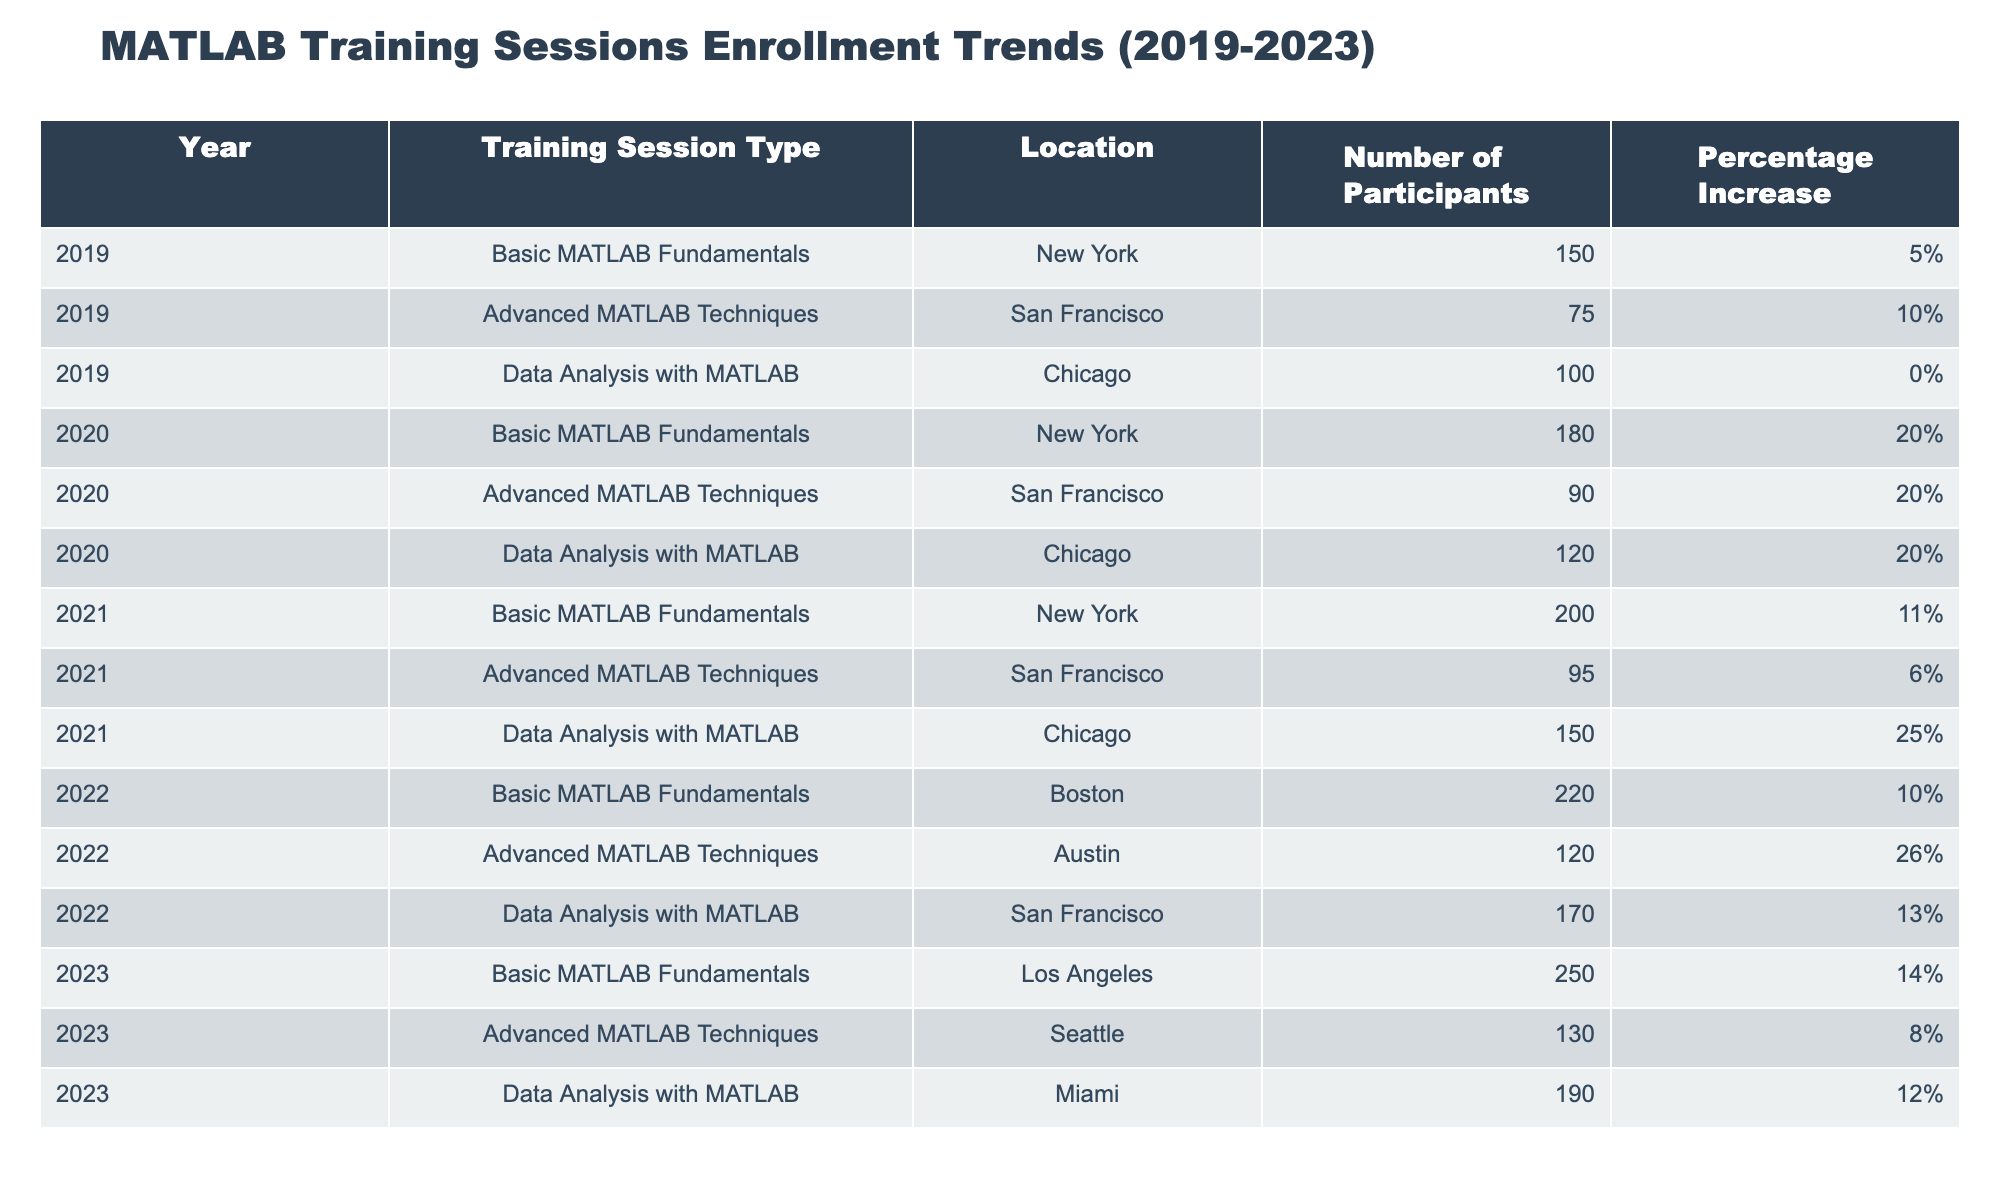What was the enrollment number for Data Analysis with MATLAB in 2021? The table shows that in 2021, the enrollment number for the "Data Analysis with MATLAB" session is listed under the year 2021 with a specific count.
Answer: 150 What was the percentage increase in the number of participants for Advanced MATLAB Techniques from 2020 to 2021? The table shows that in 2020, the number of participants for "Advanced MATLAB Techniques" was 90, and in 2021 it was 95. The percentage increase is calculated as ((95 - 90) / 90) * 100 = 5.56%, which can be rounded to about 6%.
Answer: 6% Which year had the highest number of participants for Basic MATLAB Fundamentals? By examining the table, we can see that the "Basic MATLAB Fundamentals" sessions exhibit participant numbers for each year: 150 in 2019, 180 in 2020, 200 in 2021, 220 in 2022, and 250 in 2023. The highest number is found in 2023.
Answer: 2023 Was there a year when the number of participants for Data Analysis with MATLAB decreased? A quick review of the participant numbers for "Data Analysis with MATLAB" shows that they increased each year: 100 in 2019, 120 in 2020, 150 in 2021, 170 in 2022, and 190 in 2023. Therefore, no, there was no decrease.
Answer: No What is the total number of participants across all training session types in 2022? To find the total for 2022, we add the number of participants for each session type: 220 (Basic) + 120 (Advanced) + 170 (Data Analysis) = 510.
Answer: 510 In which location did the Basic MATLAB Fundamentals session occur in 2022? The table clearly lists that the "Basic MATLAB Fundamentals" session in 2022 took place in Boston.
Answer: Boston What was the average number of participants for Advanced MATLAB Techniques over the five years? The enrollment numbers for "Advanced MATLAB Techniques" are: 75 (2019), 90 (2020), 95 (2021), 120 (2022), and 130 (2023). Calculating the average: (75 + 90 + 95 + 120 + 130) / 5 = 102.
Answer: 102 Which training session had the highest percentage increase in participants from 2021 to 2022? The percentage increases for each session can be compared: 10% (Basic) for 2022, 26% (Advanced), and 13% (Data Analysis). The highest increase is from "Advanced MATLAB Techniques," which had 26%.
Answer: Advanced MATLAB Techniques What was the total percentage increase from 2019 to 2023 for Data Analysis with MATLAB? The number of participants grew from 100 in 2019 to 190 in 2023. The total increase is 90. Calculating the percentage increase: (90 / 100) * 100 = 90%.
Answer: 90% 